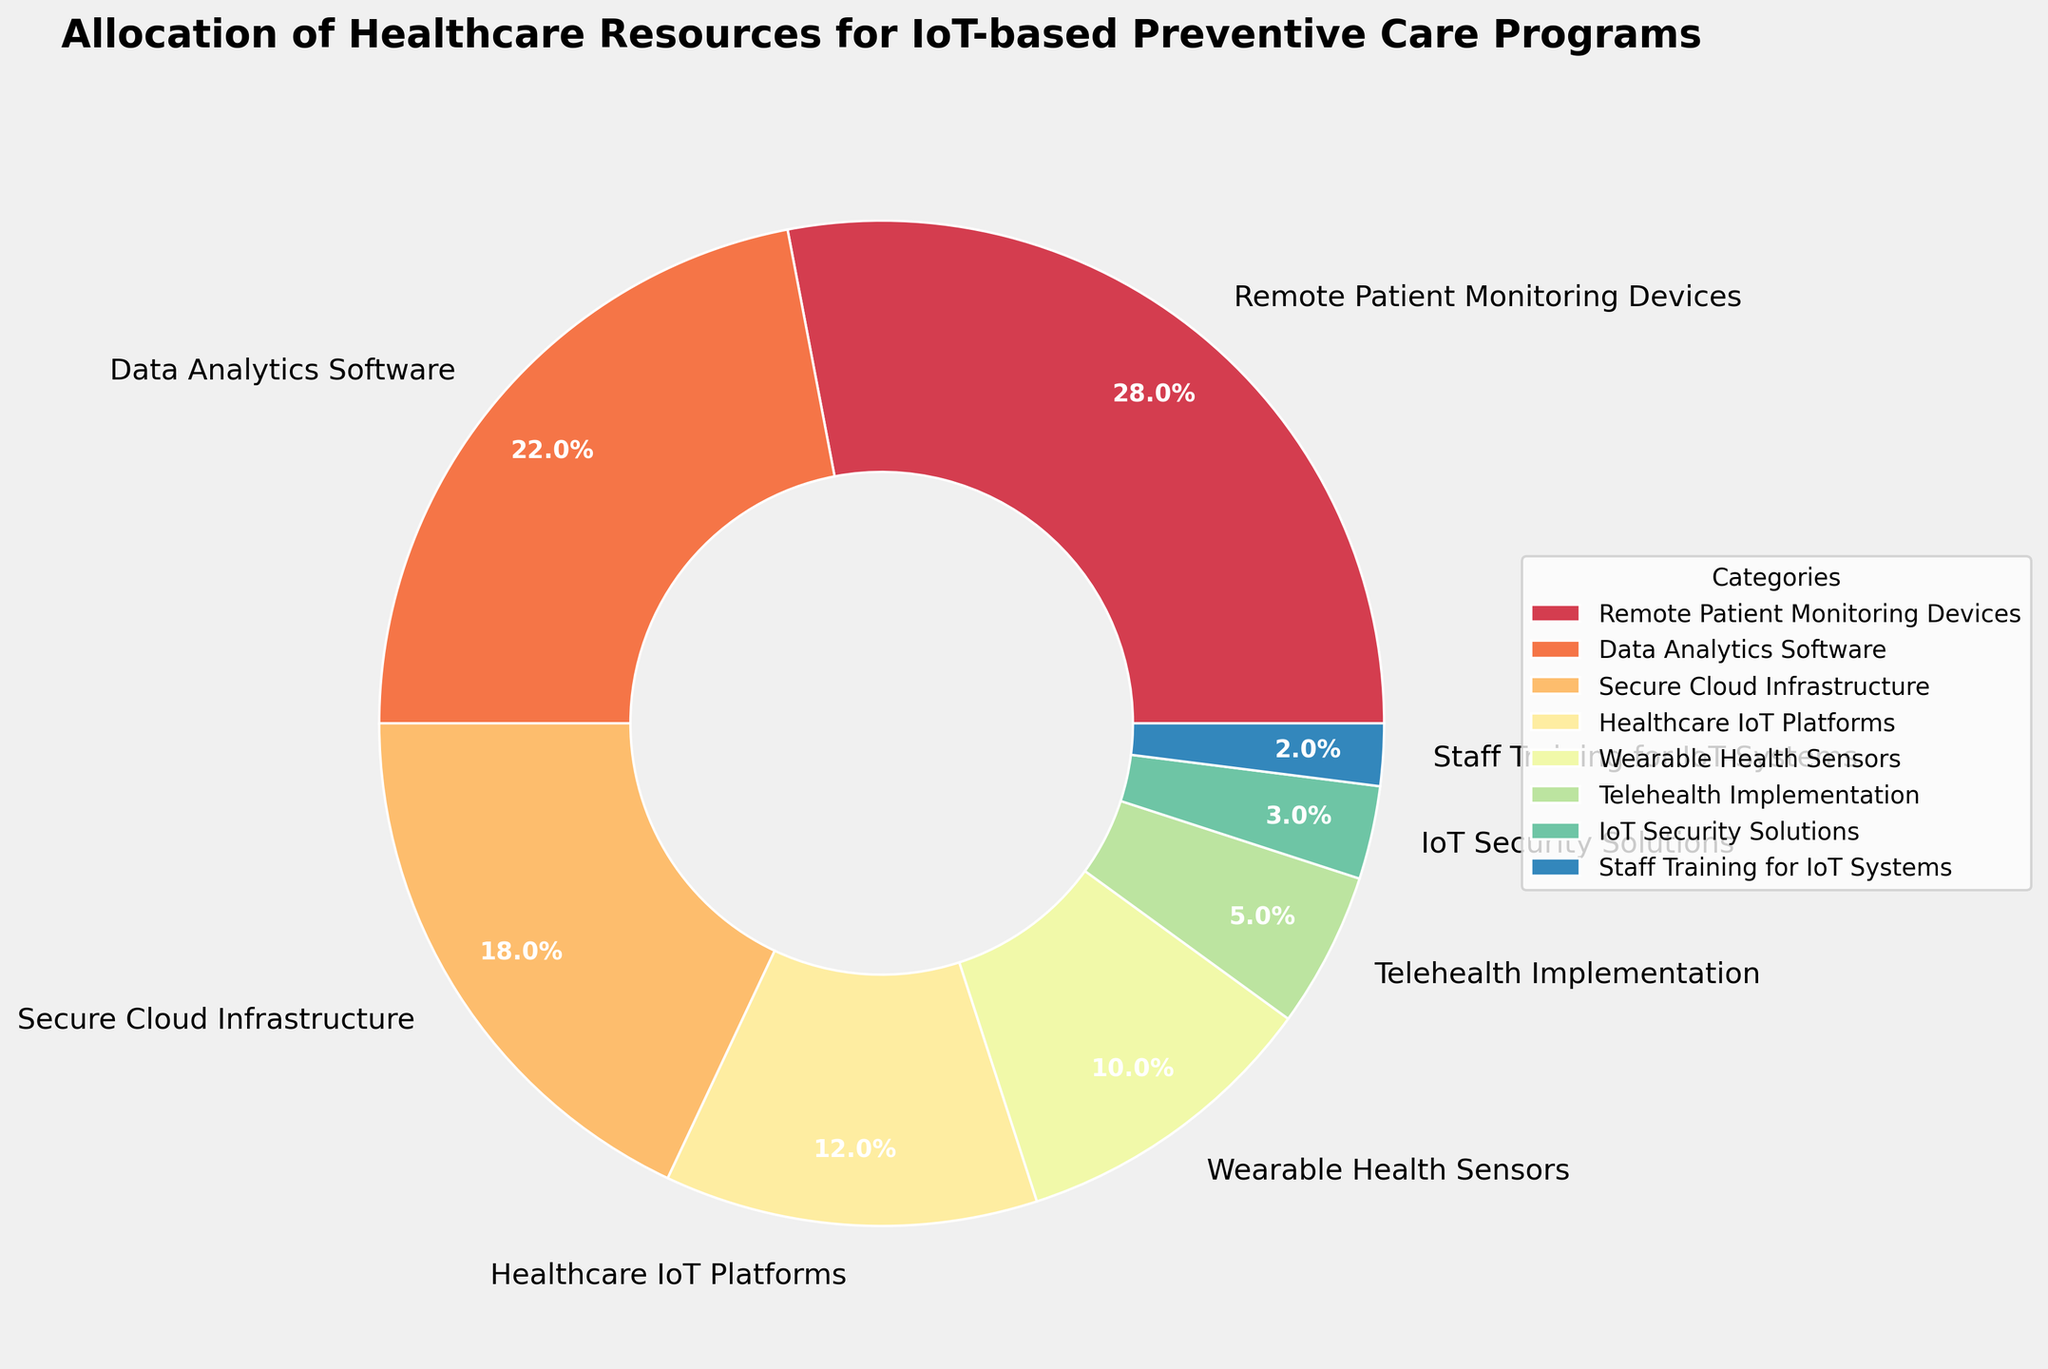Which category is allocated the highest percentage of healthcare resources? The category with the highest percentage is found by identifying the value that is the largest. "Remote Patient Monitoring Devices" holds the largest slice at 28%.
Answer: Remote Patient Monitoring Devices Which two categories together account for exactly half (50%) of the total allocation? By adding the percentages of categories, "Remote Patient Monitoring Devices" (28%) and "Data Analytics Software" (22%) together make 50%.
Answer: Remote Patient Monitoring Devices and Data Analytics Software How does the percentage allocation of Wearable Health Sensors compare to Telehealth Implementation? Wearable Health Sensors have an allocation of 10%, while Telehealth Implementation has 5%. Comparing these values, Wearable Health Sensors are allocated double (10% vs. 5%).
Answer: Wearable Health Sensors is double Telehealth Implementation Which category has the lowest allocation, and what is its percentage? The category with the lowest allocation is identified as the smallest wedge in the pie chart. "Staff Training for IoT Systems" has the smallest slice at 2%.
Answer: Staff Training for IoT Systems with 2% What's the total percentage allocation for IoT security-related categories? IoT Security Solutions (3%) and Secure Cloud Infrastructure (18%) are security-related. Their total percentage is 3% + 18% = 21%.
Answer: 21% Out of Data Analytics Software and Healthcare IoT Platforms, which one gets more resources? Comparing the wedges' sizes, Data Analytics Software (22%) gets more resources than Healthcare IoT Platforms (12%).
Answer: Data Analytics Software What is the sum of the allocations for categories related to patient monitoring? Remote Patient Monitoring Devices (28%) and Wearable Health Sensors (10%) are related to patient monitoring. Their total percentage is 28% + 10% = 38%.
Answer: 38% What percentage of resources is allocated to Telehealth Implementation compared to the Secure Cloud Infrastructure? Telehealth Implementation gets 5%, and Secure Cloud Infrastructure gets 18%. Comparatively, Telehealth Implementation receives less than a third of Secure Cloud Infrastructure’s allocation.
Answer: Less than a third Which color corresponds to Data Analytics Software in the pie chart? The categories are colored distinctively. Identifying the second largest wedge from the legend, "Data Analytics Software" is found to be represented by an intermediate color, likely a variant in the Spectral colormap used.
Answer: Intermediate color in Spectral colormap 